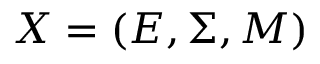<formula> <loc_0><loc_0><loc_500><loc_500>X = ( E , \Sigma , M )</formula> 